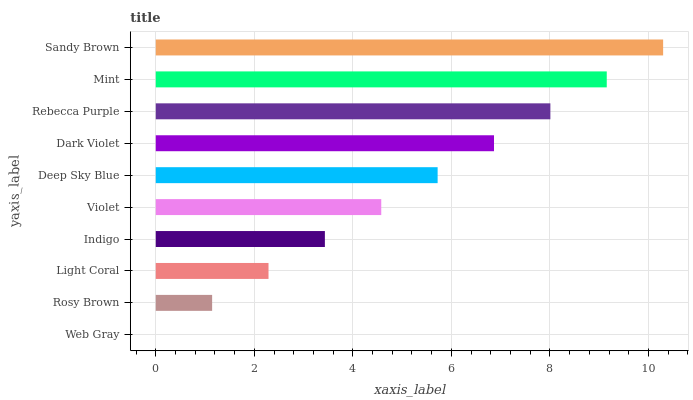Is Web Gray the minimum?
Answer yes or no. Yes. Is Sandy Brown the maximum?
Answer yes or no. Yes. Is Rosy Brown the minimum?
Answer yes or no. No. Is Rosy Brown the maximum?
Answer yes or no. No. Is Rosy Brown greater than Web Gray?
Answer yes or no. Yes. Is Web Gray less than Rosy Brown?
Answer yes or no. Yes. Is Web Gray greater than Rosy Brown?
Answer yes or no. No. Is Rosy Brown less than Web Gray?
Answer yes or no. No. Is Deep Sky Blue the high median?
Answer yes or no. Yes. Is Violet the low median?
Answer yes or no. Yes. Is Light Coral the high median?
Answer yes or no. No. Is Rosy Brown the low median?
Answer yes or no. No. 